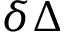Convert formula to latex. <formula><loc_0><loc_0><loc_500><loc_500>\delta \Delta</formula> 